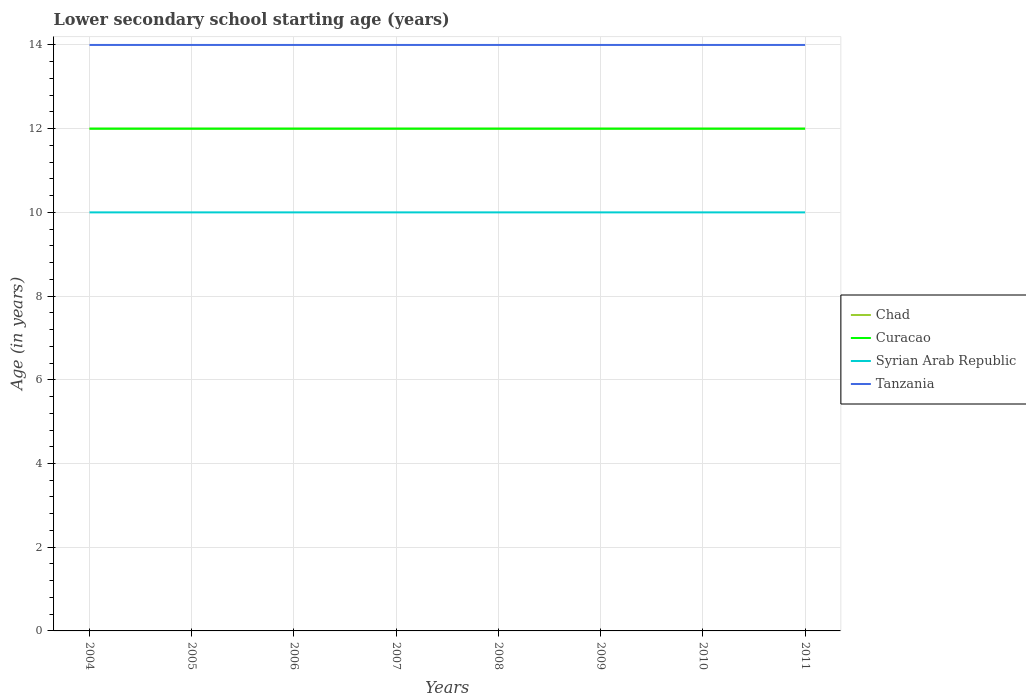How many different coloured lines are there?
Provide a short and direct response. 4. Across all years, what is the maximum lower secondary school starting age of children in Tanzania?
Your response must be concise. 14. In which year was the lower secondary school starting age of children in Syrian Arab Republic maximum?
Provide a succinct answer. 2004. What is the difference between the highest and the second highest lower secondary school starting age of children in Curacao?
Provide a succinct answer. 0. What is the difference between the highest and the lowest lower secondary school starting age of children in Syrian Arab Republic?
Make the answer very short. 0. How many years are there in the graph?
Offer a terse response. 8. Does the graph contain grids?
Make the answer very short. Yes. Where does the legend appear in the graph?
Your response must be concise. Center right. How many legend labels are there?
Give a very brief answer. 4. What is the title of the graph?
Ensure brevity in your answer.  Lower secondary school starting age (years). Does "Cambodia" appear as one of the legend labels in the graph?
Your answer should be compact. No. What is the label or title of the Y-axis?
Your answer should be compact. Age (in years). What is the Age (in years) in Tanzania in 2004?
Keep it short and to the point. 14. What is the Age (in years) in Syrian Arab Republic in 2005?
Offer a very short reply. 10. What is the Age (in years) in Syrian Arab Republic in 2006?
Make the answer very short. 10. What is the Age (in years) of Chad in 2007?
Make the answer very short. 12. What is the Age (in years) of Curacao in 2007?
Give a very brief answer. 12. What is the Age (in years) of Syrian Arab Republic in 2007?
Offer a terse response. 10. What is the Age (in years) in Syrian Arab Republic in 2008?
Provide a succinct answer. 10. What is the Age (in years) in Tanzania in 2008?
Provide a succinct answer. 14. What is the Age (in years) of Chad in 2009?
Provide a short and direct response. 12. What is the Age (in years) of Syrian Arab Republic in 2010?
Provide a succinct answer. 10. What is the Age (in years) of Tanzania in 2010?
Make the answer very short. 14. Across all years, what is the maximum Age (in years) of Curacao?
Make the answer very short. 12. Across all years, what is the maximum Age (in years) of Tanzania?
Offer a terse response. 14. Across all years, what is the minimum Age (in years) in Chad?
Offer a very short reply. 12. Across all years, what is the minimum Age (in years) of Curacao?
Your answer should be very brief. 12. Across all years, what is the minimum Age (in years) of Syrian Arab Republic?
Your answer should be compact. 10. Across all years, what is the minimum Age (in years) in Tanzania?
Provide a succinct answer. 14. What is the total Age (in years) in Chad in the graph?
Offer a very short reply. 96. What is the total Age (in years) in Curacao in the graph?
Offer a terse response. 96. What is the total Age (in years) in Syrian Arab Republic in the graph?
Offer a very short reply. 80. What is the total Age (in years) of Tanzania in the graph?
Your answer should be compact. 112. What is the difference between the Age (in years) in Chad in 2004 and that in 2005?
Provide a short and direct response. 0. What is the difference between the Age (in years) of Chad in 2004 and that in 2006?
Offer a very short reply. 0. What is the difference between the Age (in years) of Tanzania in 2004 and that in 2006?
Ensure brevity in your answer.  0. What is the difference between the Age (in years) in Chad in 2004 and that in 2007?
Keep it short and to the point. 0. What is the difference between the Age (in years) in Syrian Arab Republic in 2004 and that in 2007?
Keep it short and to the point. 0. What is the difference between the Age (in years) in Tanzania in 2004 and that in 2007?
Offer a very short reply. 0. What is the difference between the Age (in years) in Chad in 2004 and that in 2008?
Your answer should be very brief. 0. What is the difference between the Age (in years) in Curacao in 2004 and that in 2008?
Provide a short and direct response. 0. What is the difference between the Age (in years) of Tanzania in 2004 and that in 2008?
Your response must be concise. 0. What is the difference between the Age (in years) in Curacao in 2004 and that in 2009?
Make the answer very short. 0. What is the difference between the Age (in years) of Curacao in 2004 and that in 2010?
Make the answer very short. 0. What is the difference between the Age (in years) in Chad in 2005 and that in 2006?
Keep it short and to the point. 0. What is the difference between the Age (in years) in Syrian Arab Republic in 2005 and that in 2006?
Give a very brief answer. 0. What is the difference between the Age (in years) in Tanzania in 2005 and that in 2006?
Your answer should be compact. 0. What is the difference between the Age (in years) of Syrian Arab Republic in 2005 and that in 2007?
Keep it short and to the point. 0. What is the difference between the Age (in years) of Tanzania in 2005 and that in 2007?
Your response must be concise. 0. What is the difference between the Age (in years) of Curacao in 2005 and that in 2008?
Your answer should be very brief. 0. What is the difference between the Age (in years) of Curacao in 2005 and that in 2009?
Your response must be concise. 0. What is the difference between the Age (in years) of Tanzania in 2005 and that in 2009?
Offer a very short reply. 0. What is the difference between the Age (in years) in Curacao in 2005 and that in 2010?
Provide a short and direct response. 0. What is the difference between the Age (in years) of Chad in 2005 and that in 2011?
Offer a terse response. 0. What is the difference between the Age (in years) in Curacao in 2006 and that in 2007?
Offer a very short reply. 0. What is the difference between the Age (in years) in Curacao in 2006 and that in 2008?
Provide a succinct answer. 0. What is the difference between the Age (in years) in Syrian Arab Republic in 2006 and that in 2008?
Ensure brevity in your answer.  0. What is the difference between the Age (in years) in Tanzania in 2006 and that in 2008?
Offer a terse response. 0. What is the difference between the Age (in years) in Syrian Arab Republic in 2006 and that in 2010?
Your answer should be compact. 0. What is the difference between the Age (in years) in Tanzania in 2006 and that in 2010?
Your response must be concise. 0. What is the difference between the Age (in years) in Chad in 2006 and that in 2011?
Ensure brevity in your answer.  0. What is the difference between the Age (in years) of Tanzania in 2006 and that in 2011?
Keep it short and to the point. 0. What is the difference between the Age (in years) in Chad in 2007 and that in 2009?
Make the answer very short. 0. What is the difference between the Age (in years) in Syrian Arab Republic in 2007 and that in 2009?
Provide a short and direct response. 0. What is the difference between the Age (in years) of Curacao in 2007 and that in 2010?
Your answer should be very brief. 0. What is the difference between the Age (in years) of Tanzania in 2007 and that in 2010?
Make the answer very short. 0. What is the difference between the Age (in years) of Curacao in 2007 and that in 2011?
Keep it short and to the point. 0. What is the difference between the Age (in years) in Syrian Arab Republic in 2007 and that in 2011?
Give a very brief answer. 0. What is the difference between the Age (in years) in Tanzania in 2007 and that in 2011?
Offer a very short reply. 0. What is the difference between the Age (in years) in Syrian Arab Republic in 2008 and that in 2009?
Your response must be concise. 0. What is the difference between the Age (in years) of Chad in 2008 and that in 2010?
Provide a succinct answer. 0. What is the difference between the Age (in years) in Curacao in 2008 and that in 2010?
Ensure brevity in your answer.  0. What is the difference between the Age (in years) of Syrian Arab Republic in 2008 and that in 2010?
Make the answer very short. 0. What is the difference between the Age (in years) of Tanzania in 2008 and that in 2010?
Offer a terse response. 0. What is the difference between the Age (in years) in Curacao in 2008 and that in 2011?
Your response must be concise. 0. What is the difference between the Age (in years) in Syrian Arab Republic in 2008 and that in 2011?
Keep it short and to the point. 0. What is the difference between the Age (in years) in Chad in 2009 and that in 2010?
Give a very brief answer. 0. What is the difference between the Age (in years) in Curacao in 2009 and that in 2010?
Provide a succinct answer. 0. What is the difference between the Age (in years) of Tanzania in 2009 and that in 2010?
Provide a succinct answer. 0. What is the difference between the Age (in years) of Chad in 2009 and that in 2011?
Keep it short and to the point. 0. What is the difference between the Age (in years) of Curacao in 2009 and that in 2011?
Your response must be concise. 0. What is the difference between the Age (in years) in Chad in 2010 and that in 2011?
Your answer should be very brief. 0. What is the difference between the Age (in years) in Syrian Arab Republic in 2010 and that in 2011?
Ensure brevity in your answer.  0. What is the difference between the Age (in years) of Chad in 2004 and the Age (in years) of Curacao in 2005?
Ensure brevity in your answer.  0. What is the difference between the Age (in years) in Chad in 2004 and the Age (in years) in Syrian Arab Republic in 2005?
Ensure brevity in your answer.  2. What is the difference between the Age (in years) of Syrian Arab Republic in 2004 and the Age (in years) of Tanzania in 2005?
Keep it short and to the point. -4. What is the difference between the Age (in years) of Chad in 2004 and the Age (in years) of Syrian Arab Republic in 2006?
Offer a terse response. 2. What is the difference between the Age (in years) of Curacao in 2004 and the Age (in years) of Tanzania in 2006?
Offer a terse response. -2. What is the difference between the Age (in years) in Chad in 2004 and the Age (in years) in Syrian Arab Republic in 2007?
Your response must be concise. 2. What is the difference between the Age (in years) in Chad in 2004 and the Age (in years) in Tanzania in 2007?
Provide a succinct answer. -2. What is the difference between the Age (in years) of Curacao in 2004 and the Age (in years) of Tanzania in 2007?
Offer a very short reply. -2. What is the difference between the Age (in years) of Chad in 2004 and the Age (in years) of Syrian Arab Republic in 2008?
Keep it short and to the point. 2. What is the difference between the Age (in years) in Chad in 2004 and the Age (in years) in Tanzania in 2008?
Make the answer very short. -2. What is the difference between the Age (in years) in Curacao in 2004 and the Age (in years) in Syrian Arab Republic in 2008?
Make the answer very short. 2. What is the difference between the Age (in years) in Syrian Arab Republic in 2004 and the Age (in years) in Tanzania in 2008?
Keep it short and to the point. -4. What is the difference between the Age (in years) in Chad in 2004 and the Age (in years) in Curacao in 2009?
Offer a very short reply. 0. What is the difference between the Age (in years) of Chad in 2004 and the Age (in years) of Tanzania in 2009?
Offer a very short reply. -2. What is the difference between the Age (in years) of Syrian Arab Republic in 2004 and the Age (in years) of Tanzania in 2009?
Give a very brief answer. -4. What is the difference between the Age (in years) of Chad in 2004 and the Age (in years) of Curacao in 2010?
Provide a succinct answer. 0. What is the difference between the Age (in years) of Curacao in 2004 and the Age (in years) of Syrian Arab Republic in 2010?
Your answer should be compact. 2. What is the difference between the Age (in years) of Curacao in 2004 and the Age (in years) of Syrian Arab Republic in 2011?
Keep it short and to the point. 2. What is the difference between the Age (in years) of Syrian Arab Republic in 2004 and the Age (in years) of Tanzania in 2011?
Your response must be concise. -4. What is the difference between the Age (in years) in Chad in 2005 and the Age (in years) in Curacao in 2006?
Ensure brevity in your answer.  0. What is the difference between the Age (in years) of Curacao in 2005 and the Age (in years) of Syrian Arab Republic in 2006?
Provide a succinct answer. 2. What is the difference between the Age (in years) in Chad in 2005 and the Age (in years) in Curacao in 2007?
Make the answer very short. 0. What is the difference between the Age (in years) of Curacao in 2005 and the Age (in years) of Syrian Arab Republic in 2007?
Give a very brief answer. 2. What is the difference between the Age (in years) of Chad in 2005 and the Age (in years) of Curacao in 2008?
Your answer should be very brief. 0. What is the difference between the Age (in years) in Chad in 2005 and the Age (in years) in Tanzania in 2008?
Provide a succinct answer. -2. What is the difference between the Age (in years) of Curacao in 2005 and the Age (in years) of Tanzania in 2008?
Offer a terse response. -2. What is the difference between the Age (in years) of Syrian Arab Republic in 2005 and the Age (in years) of Tanzania in 2008?
Your answer should be compact. -4. What is the difference between the Age (in years) of Chad in 2005 and the Age (in years) of Curacao in 2009?
Offer a very short reply. 0. What is the difference between the Age (in years) of Chad in 2005 and the Age (in years) of Syrian Arab Republic in 2009?
Make the answer very short. 2. What is the difference between the Age (in years) in Chad in 2005 and the Age (in years) in Tanzania in 2009?
Give a very brief answer. -2. What is the difference between the Age (in years) of Syrian Arab Republic in 2005 and the Age (in years) of Tanzania in 2009?
Keep it short and to the point. -4. What is the difference between the Age (in years) in Chad in 2005 and the Age (in years) in Tanzania in 2010?
Keep it short and to the point. -2. What is the difference between the Age (in years) of Curacao in 2005 and the Age (in years) of Syrian Arab Republic in 2010?
Offer a terse response. 2. What is the difference between the Age (in years) of Syrian Arab Republic in 2005 and the Age (in years) of Tanzania in 2010?
Give a very brief answer. -4. What is the difference between the Age (in years) in Curacao in 2005 and the Age (in years) in Tanzania in 2011?
Offer a very short reply. -2. What is the difference between the Age (in years) in Syrian Arab Republic in 2005 and the Age (in years) in Tanzania in 2011?
Your response must be concise. -4. What is the difference between the Age (in years) of Chad in 2006 and the Age (in years) of Syrian Arab Republic in 2007?
Provide a succinct answer. 2. What is the difference between the Age (in years) in Curacao in 2006 and the Age (in years) in Tanzania in 2007?
Offer a very short reply. -2. What is the difference between the Age (in years) in Chad in 2006 and the Age (in years) in Curacao in 2008?
Your response must be concise. 0. What is the difference between the Age (in years) in Chad in 2006 and the Age (in years) in Syrian Arab Republic in 2008?
Your answer should be very brief. 2. What is the difference between the Age (in years) in Chad in 2006 and the Age (in years) in Tanzania in 2008?
Give a very brief answer. -2. What is the difference between the Age (in years) in Curacao in 2006 and the Age (in years) in Tanzania in 2008?
Keep it short and to the point. -2. What is the difference between the Age (in years) in Chad in 2006 and the Age (in years) in Syrian Arab Republic in 2009?
Ensure brevity in your answer.  2. What is the difference between the Age (in years) of Syrian Arab Republic in 2006 and the Age (in years) of Tanzania in 2009?
Your answer should be compact. -4. What is the difference between the Age (in years) in Chad in 2006 and the Age (in years) in Tanzania in 2010?
Your answer should be compact. -2. What is the difference between the Age (in years) in Curacao in 2006 and the Age (in years) in Syrian Arab Republic in 2010?
Make the answer very short. 2. What is the difference between the Age (in years) of Curacao in 2006 and the Age (in years) of Tanzania in 2011?
Your response must be concise. -2. What is the difference between the Age (in years) in Syrian Arab Republic in 2006 and the Age (in years) in Tanzania in 2011?
Your response must be concise. -4. What is the difference between the Age (in years) of Chad in 2007 and the Age (in years) of Curacao in 2008?
Keep it short and to the point. 0. What is the difference between the Age (in years) in Chad in 2007 and the Age (in years) in Syrian Arab Republic in 2008?
Provide a short and direct response. 2. What is the difference between the Age (in years) in Curacao in 2007 and the Age (in years) in Syrian Arab Republic in 2008?
Give a very brief answer. 2. What is the difference between the Age (in years) of Curacao in 2007 and the Age (in years) of Tanzania in 2008?
Make the answer very short. -2. What is the difference between the Age (in years) in Syrian Arab Republic in 2007 and the Age (in years) in Tanzania in 2008?
Your answer should be very brief. -4. What is the difference between the Age (in years) in Chad in 2007 and the Age (in years) in Curacao in 2010?
Provide a short and direct response. 0. What is the difference between the Age (in years) of Chad in 2007 and the Age (in years) of Syrian Arab Republic in 2010?
Give a very brief answer. 2. What is the difference between the Age (in years) of Chad in 2007 and the Age (in years) of Tanzania in 2010?
Offer a very short reply. -2. What is the difference between the Age (in years) in Curacao in 2007 and the Age (in years) in Tanzania in 2010?
Provide a succinct answer. -2. What is the difference between the Age (in years) in Chad in 2007 and the Age (in years) in Curacao in 2011?
Make the answer very short. 0. What is the difference between the Age (in years) of Chad in 2007 and the Age (in years) of Syrian Arab Republic in 2011?
Your answer should be very brief. 2. What is the difference between the Age (in years) of Chad in 2008 and the Age (in years) of Curacao in 2009?
Make the answer very short. 0. What is the difference between the Age (in years) of Curacao in 2008 and the Age (in years) of Syrian Arab Republic in 2009?
Offer a terse response. 2. What is the difference between the Age (in years) in Curacao in 2008 and the Age (in years) in Tanzania in 2009?
Give a very brief answer. -2. What is the difference between the Age (in years) of Syrian Arab Republic in 2008 and the Age (in years) of Tanzania in 2009?
Make the answer very short. -4. What is the difference between the Age (in years) of Chad in 2008 and the Age (in years) of Syrian Arab Republic in 2010?
Provide a short and direct response. 2. What is the difference between the Age (in years) of Syrian Arab Republic in 2008 and the Age (in years) of Tanzania in 2010?
Your answer should be very brief. -4. What is the difference between the Age (in years) in Chad in 2008 and the Age (in years) in Tanzania in 2011?
Ensure brevity in your answer.  -2. What is the difference between the Age (in years) of Curacao in 2008 and the Age (in years) of Syrian Arab Republic in 2011?
Make the answer very short. 2. What is the difference between the Age (in years) of Curacao in 2008 and the Age (in years) of Tanzania in 2011?
Your answer should be very brief. -2. What is the difference between the Age (in years) of Syrian Arab Republic in 2008 and the Age (in years) of Tanzania in 2011?
Your response must be concise. -4. What is the difference between the Age (in years) of Chad in 2009 and the Age (in years) of Curacao in 2010?
Keep it short and to the point. 0. What is the difference between the Age (in years) of Chad in 2009 and the Age (in years) of Tanzania in 2010?
Offer a terse response. -2. What is the difference between the Age (in years) in Chad in 2009 and the Age (in years) in Tanzania in 2011?
Provide a succinct answer. -2. What is the difference between the Age (in years) in Syrian Arab Republic in 2009 and the Age (in years) in Tanzania in 2011?
Your response must be concise. -4. What is the difference between the Age (in years) in Chad in 2010 and the Age (in years) in Syrian Arab Republic in 2011?
Ensure brevity in your answer.  2. What is the difference between the Age (in years) in Curacao in 2010 and the Age (in years) in Syrian Arab Republic in 2011?
Make the answer very short. 2. In the year 2004, what is the difference between the Age (in years) of Chad and Age (in years) of Curacao?
Give a very brief answer. 0. In the year 2004, what is the difference between the Age (in years) in Chad and Age (in years) in Syrian Arab Republic?
Offer a very short reply. 2. In the year 2004, what is the difference between the Age (in years) in Curacao and Age (in years) in Syrian Arab Republic?
Your response must be concise. 2. In the year 2004, what is the difference between the Age (in years) in Curacao and Age (in years) in Tanzania?
Your answer should be compact. -2. In the year 2004, what is the difference between the Age (in years) in Syrian Arab Republic and Age (in years) in Tanzania?
Keep it short and to the point. -4. In the year 2005, what is the difference between the Age (in years) of Chad and Age (in years) of Curacao?
Provide a short and direct response. 0. In the year 2005, what is the difference between the Age (in years) of Chad and Age (in years) of Syrian Arab Republic?
Ensure brevity in your answer.  2. In the year 2005, what is the difference between the Age (in years) in Curacao and Age (in years) in Syrian Arab Republic?
Offer a terse response. 2. In the year 2005, what is the difference between the Age (in years) in Syrian Arab Republic and Age (in years) in Tanzania?
Make the answer very short. -4. In the year 2006, what is the difference between the Age (in years) of Chad and Age (in years) of Curacao?
Offer a terse response. 0. In the year 2006, what is the difference between the Age (in years) of Curacao and Age (in years) of Syrian Arab Republic?
Offer a terse response. 2. In the year 2007, what is the difference between the Age (in years) in Chad and Age (in years) in Syrian Arab Republic?
Keep it short and to the point. 2. In the year 2007, what is the difference between the Age (in years) of Curacao and Age (in years) of Syrian Arab Republic?
Your answer should be compact. 2. In the year 2007, what is the difference between the Age (in years) in Curacao and Age (in years) in Tanzania?
Offer a very short reply. -2. In the year 2007, what is the difference between the Age (in years) of Syrian Arab Republic and Age (in years) of Tanzania?
Make the answer very short. -4. In the year 2008, what is the difference between the Age (in years) in Chad and Age (in years) in Syrian Arab Republic?
Provide a short and direct response. 2. In the year 2008, what is the difference between the Age (in years) in Chad and Age (in years) in Tanzania?
Keep it short and to the point. -2. In the year 2008, what is the difference between the Age (in years) in Curacao and Age (in years) in Syrian Arab Republic?
Provide a short and direct response. 2. In the year 2008, what is the difference between the Age (in years) in Curacao and Age (in years) in Tanzania?
Provide a short and direct response. -2. In the year 2009, what is the difference between the Age (in years) of Syrian Arab Republic and Age (in years) of Tanzania?
Make the answer very short. -4. In the year 2010, what is the difference between the Age (in years) in Chad and Age (in years) in Curacao?
Make the answer very short. 0. In the year 2010, what is the difference between the Age (in years) in Chad and Age (in years) in Syrian Arab Republic?
Give a very brief answer. 2. In the year 2010, what is the difference between the Age (in years) in Curacao and Age (in years) in Syrian Arab Republic?
Provide a succinct answer. 2. In the year 2010, what is the difference between the Age (in years) of Syrian Arab Republic and Age (in years) of Tanzania?
Keep it short and to the point. -4. In the year 2011, what is the difference between the Age (in years) in Chad and Age (in years) in Curacao?
Make the answer very short. 0. In the year 2011, what is the difference between the Age (in years) in Chad and Age (in years) in Tanzania?
Provide a short and direct response. -2. What is the ratio of the Age (in years) of Syrian Arab Republic in 2004 to that in 2005?
Offer a very short reply. 1. What is the ratio of the Age (in years) of Tanzania in 2004 to that in 2005?
Give a very brief answer. 1. What is the ratio of the Age (in years) in Chad in 2004 to that in 2006?
Give a very brief answer. 1. What is the ratio of the Age (in years) of Tanzania in 2004 to that in 2006?
Provide a succinct answer. 1. What is the ratio of the Age (in years) in Tanzania in 2004 to that in 2007?
Your response must be concise. 1. What is the ratio of the Age (in years) in Chad in 2004 to that in 2008?
Ensure brevity in your answer.  1. What is the ratio of the Age (in years) of Curacao in 2004 to that in 2008?
Your answer should be very brief. 1. What is the ratio of the Age (in years) in Tanzania in 2004 to that in 2008?
Ensure brevity in your answer.  1. What is the ratio of the Age (in years) of Chad in 2004 to that in 2010?
Give a very brief answer. 1. What is the ratio of the Age (in years) of Syrian Arab Republic in 2004 to that in 2010?
Make the answer very short. 1. What is the ratio of the Age (in years) in Syrian Arab Republic in 2004 to that in 2011?
Offer a very short reply. 1. What is the ratio of the Age (in years) of Tanzania in 2004 to that in 2011?
Your answer should be very brief. 1. What is the ratio of the Age (in years) of Tanzania in 2005 to that in 2006?
Ensure brevity in your answer.  1. What is the ratio of the Age (in years) in Chad in 2005 to that in 2007?
Make the answer very short. 1. What is the ratio of the Age (in years) in Curacao in 2005 to that in 2007?
Your response must be concise. 1. What is the ratio of the Age (in years) in Syrian Arab Republic in 2005 to that in 2007?
Offer a terse response. 1. What is the ratio of the Age (in years) of Chad in 2005 to that in 2008?
Provide a short and direct response. 1. What is the ratio of the Age (in years) of Tanzania in 2005 to that in 2008?
Offer a terse response. 1. What is the ratio of the Age (in years) in Chad in 2005 to that in 2009?
Keep it short and to the point. 1. What is the ratio of the Age (in years) in Syrian Arab Republic in 2005 to that in 2009?
Offer a very short reply. 1. What is the ratio of the Age (in years) of Tanzania in 2005 to that in 2009?
Your answer should be very brief. 1. What is the ratio of the Age (in years) of Chad in 2005 to that in 2010?
Your answer should be very brief. 1. What is the ratio of the Age (in years) of Curacao in 2005 to that in 2010?
Your answer should be very brief. 1. What is the ratio of the Age (in years) of Chad in 2005 to that in 2011?
Offer a terse response. 1. What is the ratio of the Age (in years) in Syrian Arab Republic in 2005 to that in 2011?
Your answer should be very brief. 1. What is the ratio of the Age (in years) in Tanzania in 2005 to that in 2011?
Make the answer very short. 1. What is the ratio of the Age (in years) in Chad in 2006 to that in 2007?
Keep it short and to the point. 1. What is the ratio of the Age (in years) in Curacao in 2006 to that in 2007?
Give a very brief answer. 1. What is the ratio of the Age (in years) in Syrian Arab Republic in 2006 to that in 2007?
Your answer should be very brief. 1. What is the ratio of the Age (in years) in Tanzania in 2006 to that in 2007?
Your response must be concise. 1. What is the ratio of the Age (in years) in Curacao in 2006 to that in 2008?
Keep it short and to the point. 1. What is the ratio of the Age (in years) of Tanzania in 2006 to that in 2008?
Keep it short and to the point. 1. What is the ratio of the Age (in years) in Curacao in 2006 to that in 2009?
Your answer should be very brief. 1. What is the ratio of the Age (in years) of Syrian Arab Republic in 2006 to that in 2009?
Make the answer very short. 1. What is the ratio of the Age (in years) of Tanzania in 2006 to that in 2009?
Make the answer very short. 1. What is the ratio of the Age (in years) in Curacao in 2006 to that in 2010?
Make the answer very short. 1. What is the ratio of the Age (in years) in Syrian Arab Republic in 2006 to that in 2010?
Give a very brief answer. 1. What is the ratio of the Age (in years) in Curacao in 2006 to that in 2011?
Provide a short and direct response. 1. What is the ratio of the Age (in years) of Syrian Arab Republic in 2006 to that in 2011?
Your answer should be compact. 1. What is the ratio of the Age (in years) in Chad in 2007 to that in 2008?
Ensure brevity in your answer.  1. What is the ratio of the Age (in years) of Syrian Arab Republic in 2007 to that in 2008?
Your answer should be compact. 1. What is the ratio of the Age (in years) of Tanzania in 2007 to that in 2008?
Keep it short and to the point. 1. What is the ratio of the Age (in years) of Syrian Arab Republic in 2007 to that in 2009?
Offer a very short reply. 1. What is the ratio of the Age (in years) in Tanzania in 2007 to that in 2009?
Ensure brevity in your answer.  1. What is the ratio of the Age (in years) in Syrian Arab Republic in 2007 to that in 2010?
Offer a very short reply. 1. What is the ratio of the Age (in years) in Chad in 2007 to that in 2011?
Make the answer very short. 1. What is the ratio of the Age (in years) in Tanzania in 2007 to that in 2011?
Offer a very short reply. 1. What is the ratio of the Age (in years) in Tanzania in 2008 to that in 2009?
Your answer should be very brief. 1. What is the ratio of the Age (in years) in Chad in 2008 to that in 2010?
Your response must be concise. 1. What is the ratio of the Age (in years) in Chad in 2008 to that in 2011?
Provide a short and direct response. 1. What is the ratio of the Age (in years) in Syrian Arab Republic in 2008 to that in 2011?
Provide a succinct answer. 1. What is the ratio of the Age (in years) of Tanzania in 2008 to that in 2011?
Make the answer very short. 1. What is the ratio of the Age (in years) in Curacao in 2009 to that in 2010?
Offer a very short reply. 1. What is the ratio of the Age (in years) of Tanzania in 2009 to that in 2010?
Offer a terse response. 1. What is the ratio of the Age (in years) of Curacao in 2009 to that in 2011?
Make the answer very short. 1. What is the ratio of the Age (in years) in Syrian Arab Republic in 2010 to that in 2011?
Keep it short and to the point. 1. What is the ratio of the Age (in years) in Tanzania in 2010 to that in 2011?
Provide a succinct answer. 1. What is the difference between the highest and the second highest Age (in years) in Curacao?
Provide a succinct answer. 0. What is the difference between the highest and the lowest Age (in years) in Curacao?
Your response must be concise. 0. 